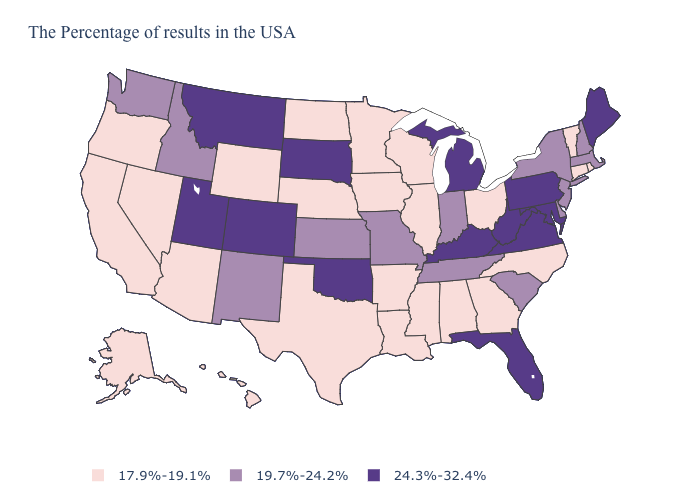Does Indiana have the same value as West Virginia?
Concise answer only. No. What is the value of Alabama?
Short answer required. 17.9%-19.1%. Name the states that have a value in the range 19.7%-24.2%?
Answer briefly. Massachusetts, New Hampshire, New York, New Jersey, Delaware, South Carolina, Indiana, Tennessee, Missouri, Kansas, New Mexico, Idaho, Washington. What is the value of Kentucky?
Keep it brief. 24.3%-32.4%. Does the first symbol in the legend represent the smallest category?
Answer briefly. Yes. Which states have the highest value in the USA?
Concise answer only. Maine, Maryland, Pennsylvania, Virginia, West Virginia, Florida, Michigan, Kentucky, Oklahoma, South Dakota, Colorado, Utah, Montana. Name the states that have a value in the range 24.3%-32.4%?
Give a very brief answer. Maine, Maryland, Pennsylvania, Virginia, West Virginia, Florida, Michigan, Kentucky, Oklahoma, South Dakota, Colorado, Utah, Montana. What is the highest value in the USA?
Give a very brief answer. 24.3%-32.4%. What is the value of New Mexico?
Quick response, please. 19.7%-24.2%. What is the highest value in the Northeast ?
Write a very short answer. 24.3%-32.4%. Which states have the highest value in the USA?
Concise answer only. Maine, Maryland, Pennsylvania, Virginia, West Virginia, Florida, Michigan, Kentucky, Oklahoma, South Dakota, Colorado, Utah, Montana. Does Nevada have the same value as Oregon?
Be succinct. Yes. What is the highest value in states that border Ohio?
Give a very brief answer. 24.3%-32.4%. Which states have the lowest value in the MidWest?
Keep it brief. Ohio, Wisconsin, Illinois, Minnesota, Iowa, Nebraska, North Dakota. 